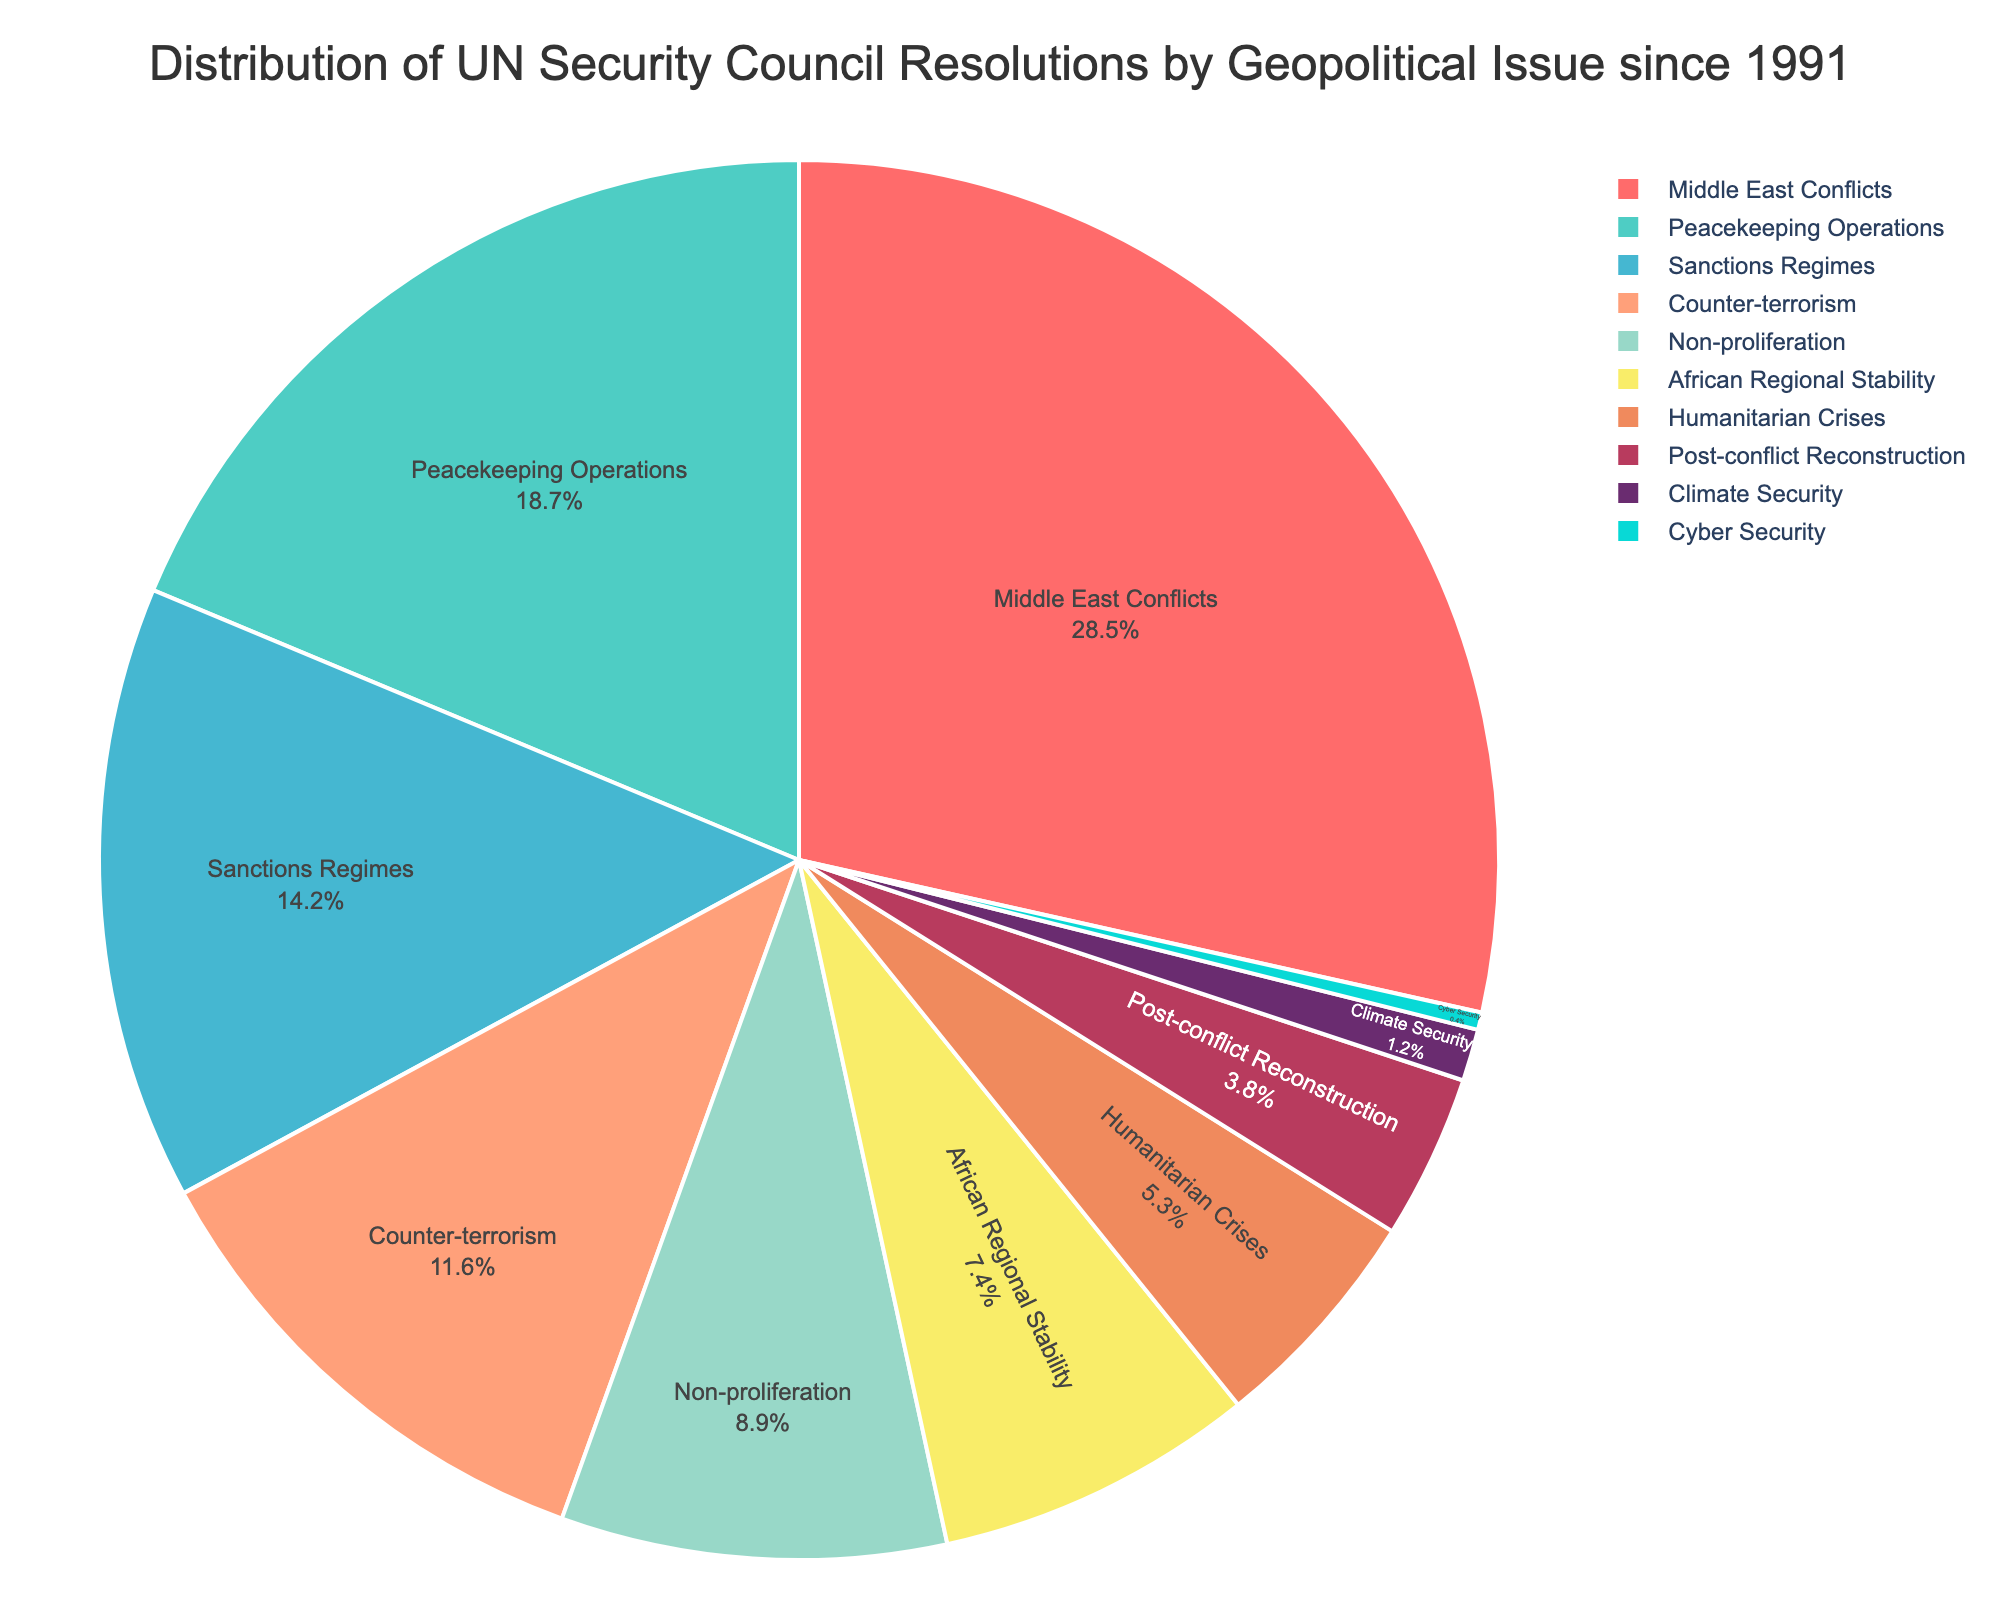Which geopolitical issue has the highest percentage of UN Security Council resolutions? Look at the pie chart and identify the segment that occupies the largest portion. The largest segment in the pie chart shows "Middle East Conflicts" with 28.5%.
Answer: Middle East Conflicts Which two issues combined make up less than 5% of the resolutions? Locate the percentages of all issues on the pie chart and add them up. "Climate Security" (1.2%) and "Cyber Security" (0.4%) together add up to 1.6%, which is less than 5%.
Answer: Climate Security and Cyber Security How much higher is the percentage of "Middle East Conflicts" compared to "Peacekeeping Operations"? Subtract the percentage of "Peacekeeping Operations" (18.7%) from "Middle East Conflicts" (28.5%). The calculation is 28.5% - 18.7% = 9.8%.
Answer: 9.8% What is the total percentage of resolutions related to "Sanctions Regimes" and "Counter-terrorism"? Add the percentage of "Sanctions Regimes" (14.2%) and "Counter-terrorism" (11.6%) together. The calculation is 14.2% + 11.6% = 25.8%.
Answer: 25.8% Which geopolitical issue has the third-highest percentage of UN resolutions? Rank the percentages listed in the pie chart. The third-highest percentage is for "Sanctions Regimes" at 14.2%.
Answer: Sanctions Regimes Is the percentage of "Humanitarian Crises" greater than "Post-conflict Reconstruction"? Compare the percentages for "Humanitarian Crises" (5.3%) and "Post-conflict Reconstruction" (3.8%). 5.3% is greater than 3.8%.
Answer: Yes What is the difference in percentage between "African Regional Stability" and "Non-proliferation"? Subtract the percentage of "Non-proliferation" (8.9%) from "African Regional Stability" (7.4%). The calculation is 8.9% - 7.4% = -1.5%.
Answer: -1.5% What combined percentage do "African Regional Stability," "Humanitarian Crises," and "Post-conflict Reconstruction" make up? Add the percentages of "African Regional Stability" (7.4%), "Humanitarian Crises" (5.3%), and "Post-conflict Reconstruction" (3.8%). The calculation is 7.4% + 5.3% + 3.8% = 16.5%.
Answer: 16.5% 